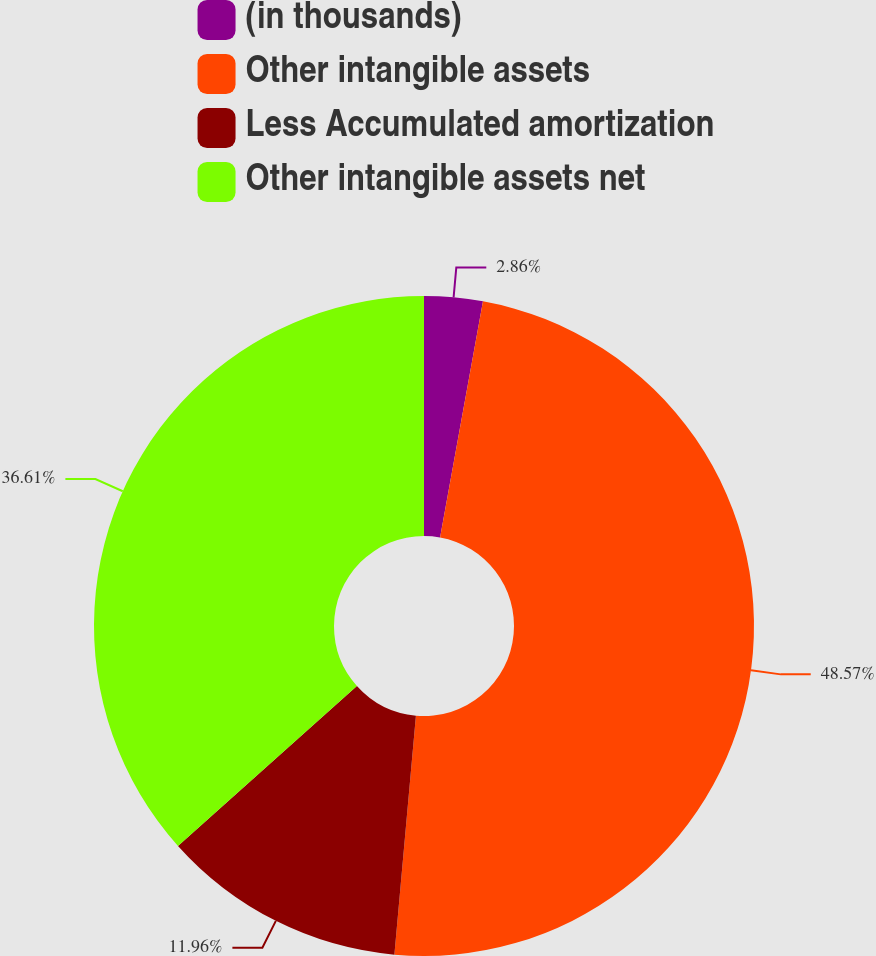Convert chart to OTSL. <chart><loc_0><loc_0><loc_500><loc_500><pie_chart><fcel>(in thousands)<fcel>Other intangible assets<fcel>Less Accumulated amortization<fcel>Other intangible assets net<nl><fcel>2.86%<fcel>48.57%<fcel>11.96%<fcel>36.61%<nl></chart> 